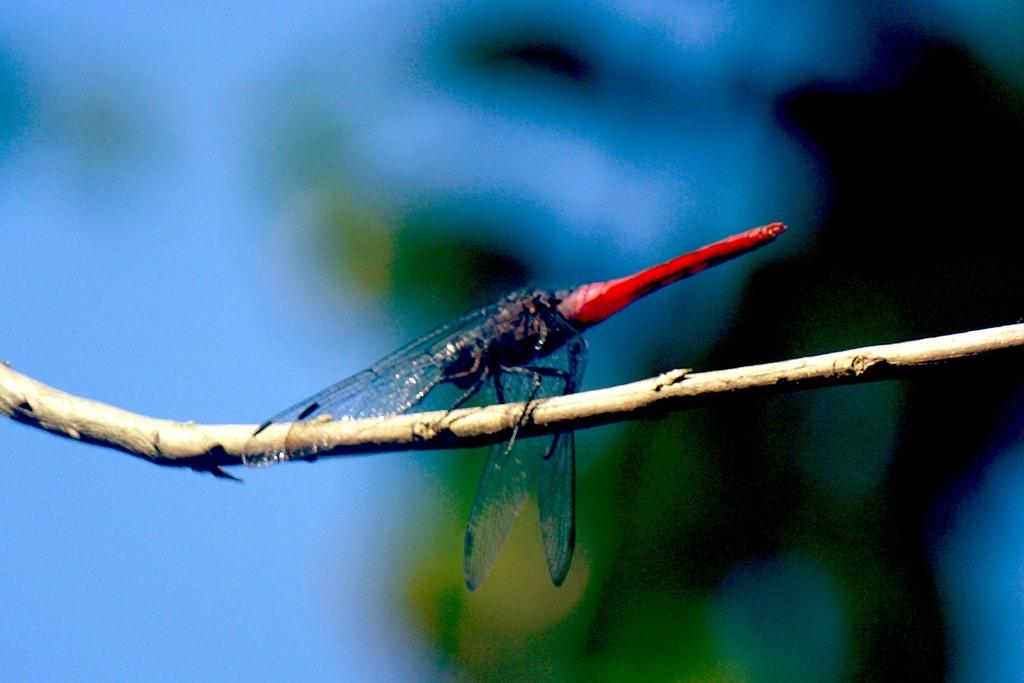What is the main subject of the image? There is a dragonfly in the image. How is the dragonfly positioned in the image? The dragonfly is on a stick. Can you describe the background of the image? The background of the image is blurry. What type of trousers is the dragonfly wearing in the image? Dragonflies do not wear trousers, as they are insects and do not have clothing. 